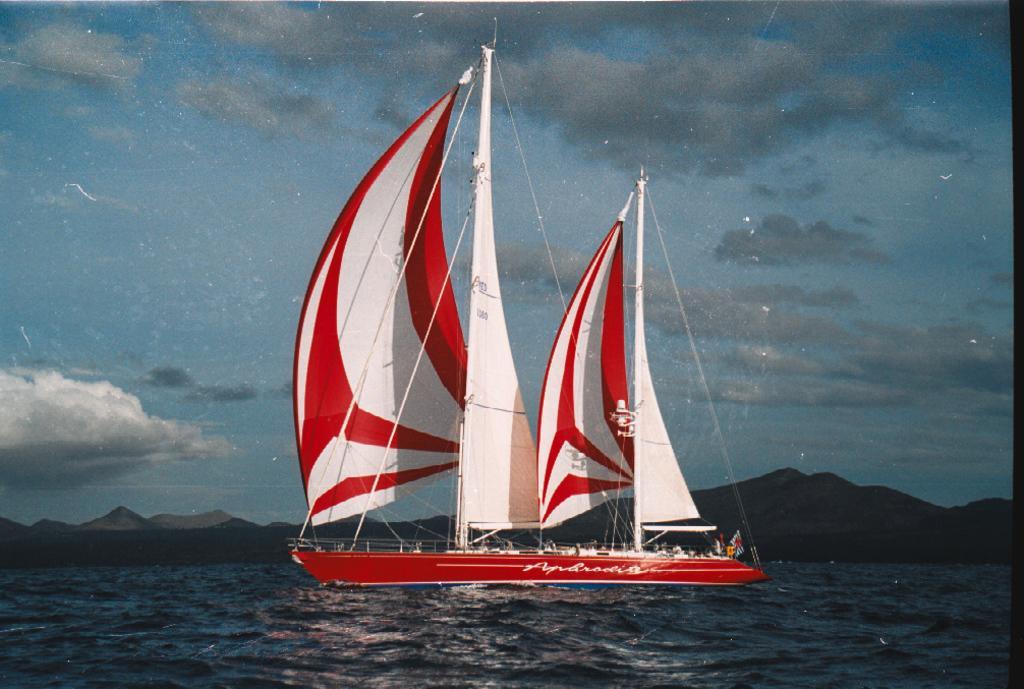In one or two sentences, can you explain what this image depicts? This is an outside view. Here I can see a ship on the water. In the background there are few hills. At the top of the image I can see the sky and clouds. 